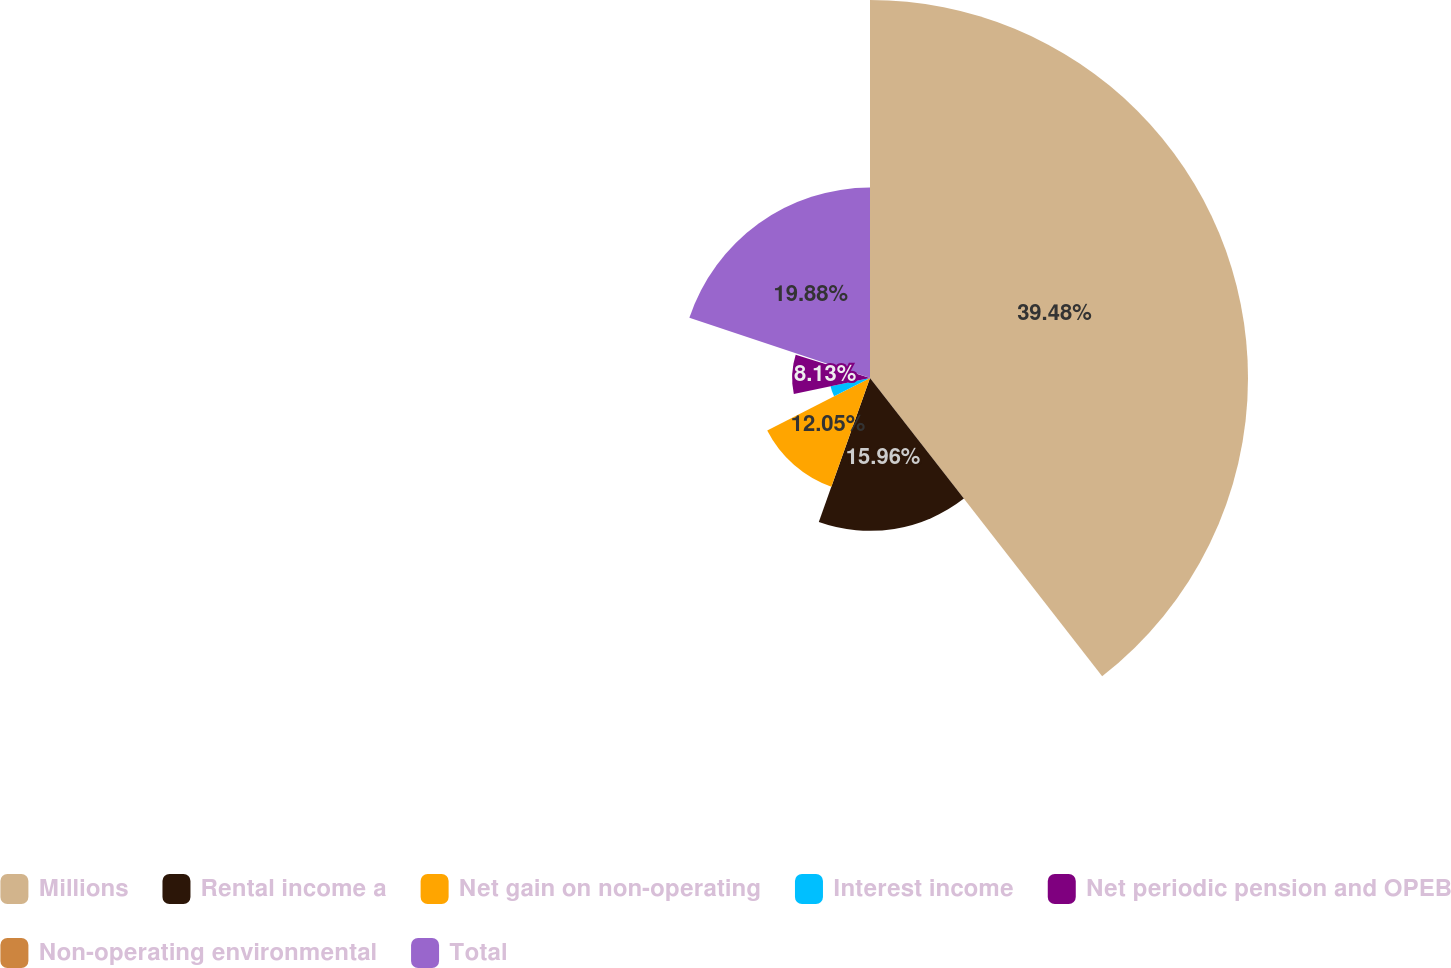<chart> <loc_0><loc_0><loc_500><loc_500><pie_chart><fcel>Millions<fcel>Rental income a<fcel>Net gain on non-operating<fcel>Interest income<fcel>Net periodic pension and OPEB<fcel>Non-operating environmental<fcel>Total<nl><fcel>39.47%<fcel>15.96%<fcel>12.05%<fcel>4.21%<fcel>8.13%<fcel>0.29%<fcel>19.88%<nl></chart> 